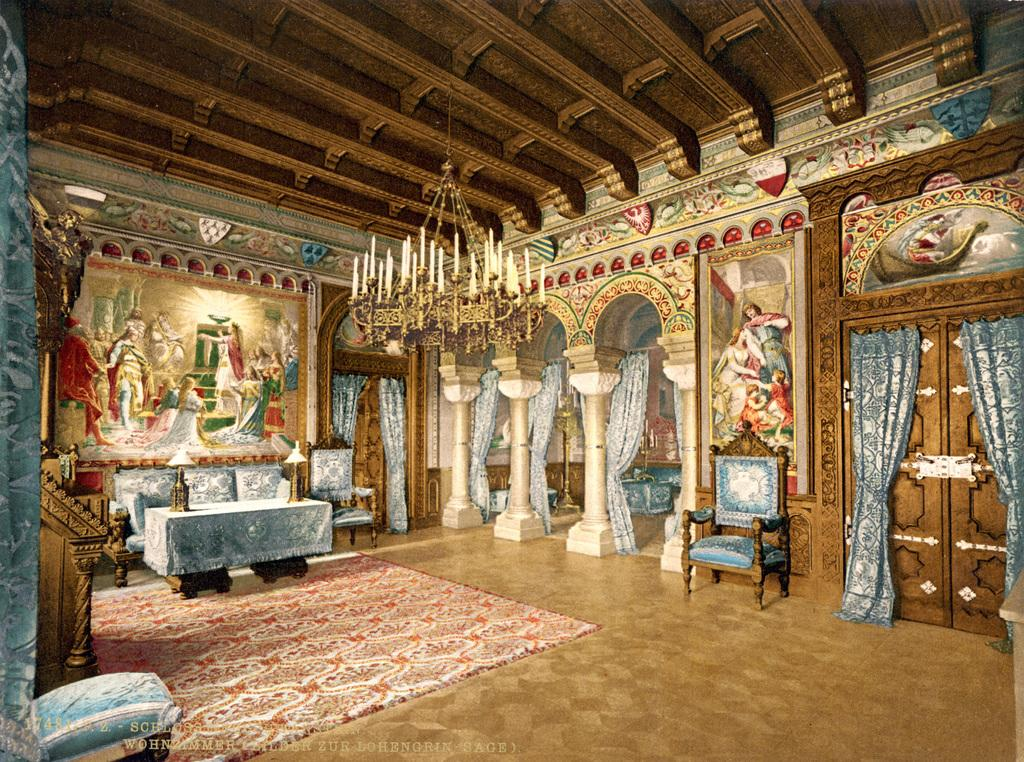What type of space is depicted in the image? The image shows an inside view of a room. What type of window treatment is present in the room? There are curtains in the room. What type of furniture is present in the room? There are chairs and a table in the room. What type of decoration is present on the wall in the room? There is a painting on the wall in the room. What type of advice is given by the cloud in the image? There is no cloud present in the image, and therefore no advice can be given by it. 